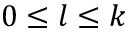Convert formula to latex. <formula><loc_0><loc_0><loc_500><loc_500>0 \leq l \leq k</formula> 